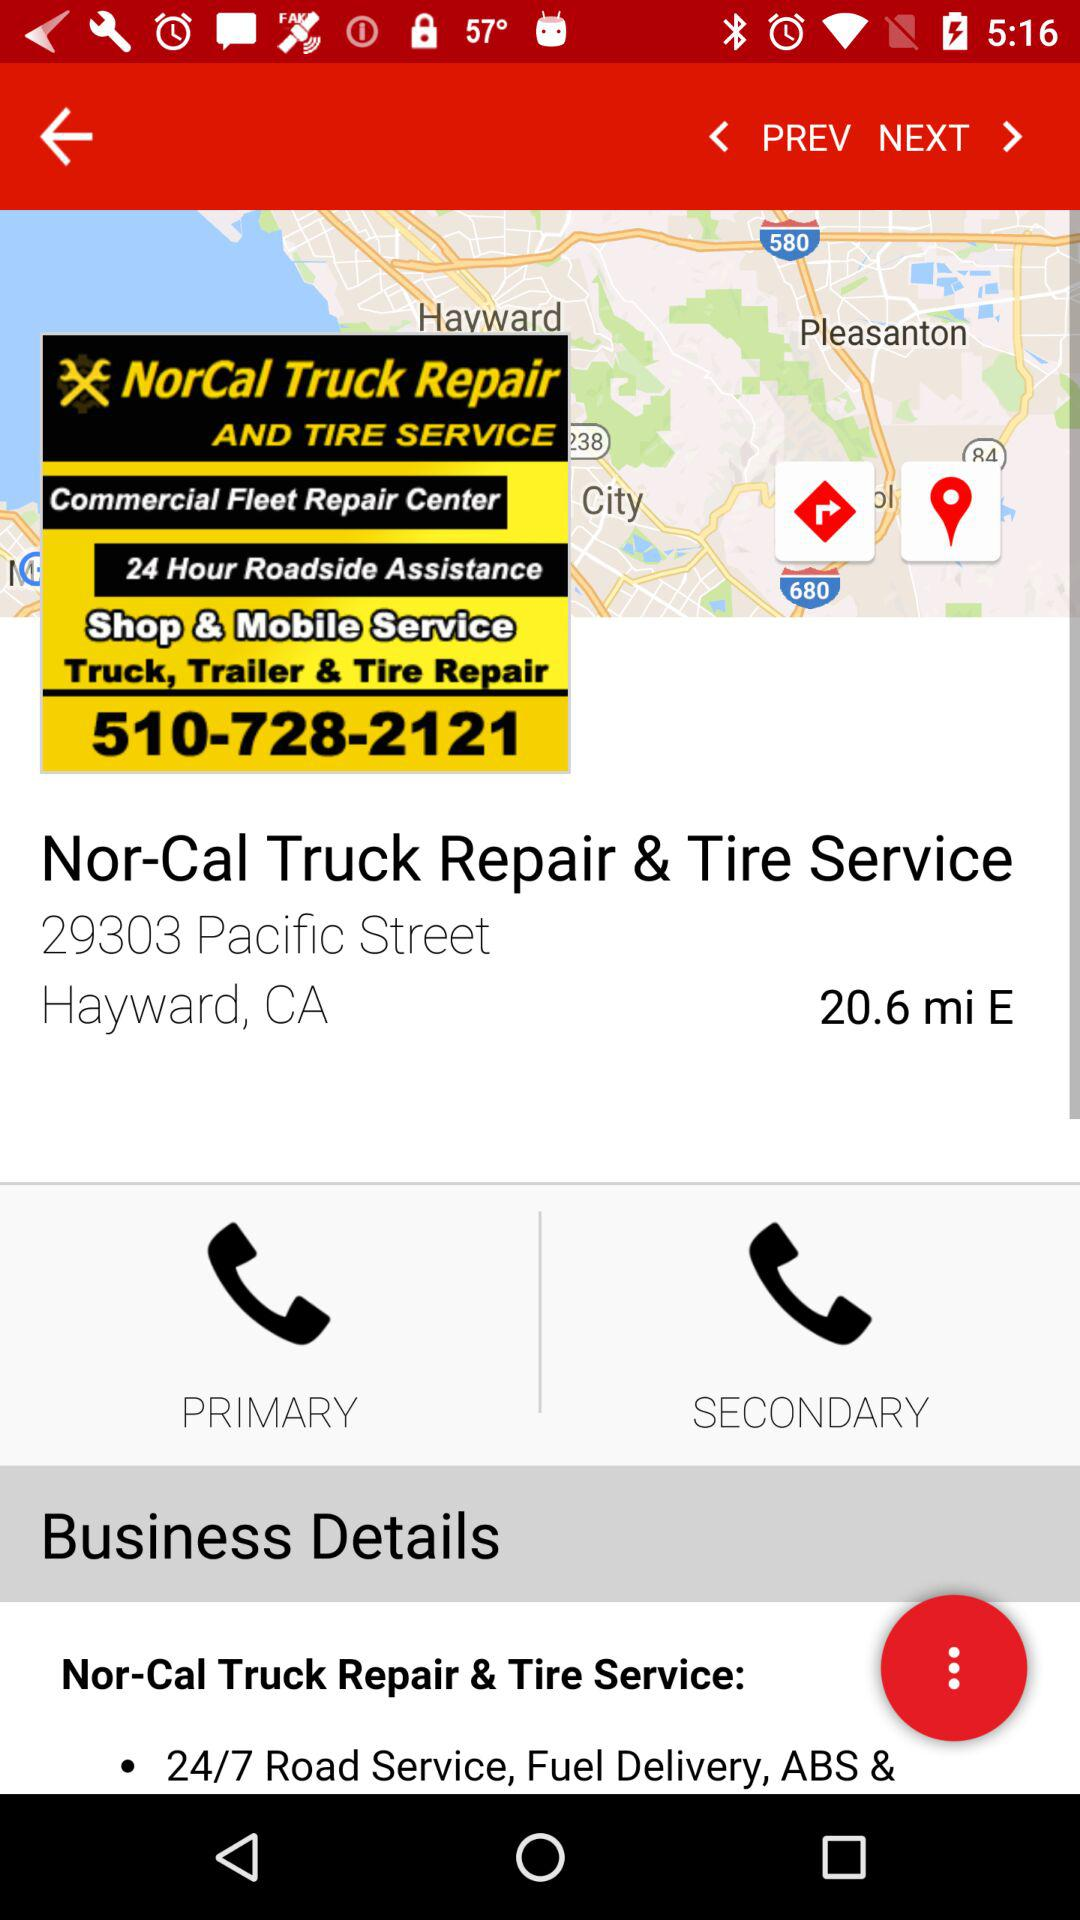What other services does Nor-Cal Truck Repair & Tire Service provide? The services are : "Commercial Fleet Repair Center", "24 Hour Roadside Assistance", "Shop & Mobile Service",and "Truck, Trailer & Tire Repair". 